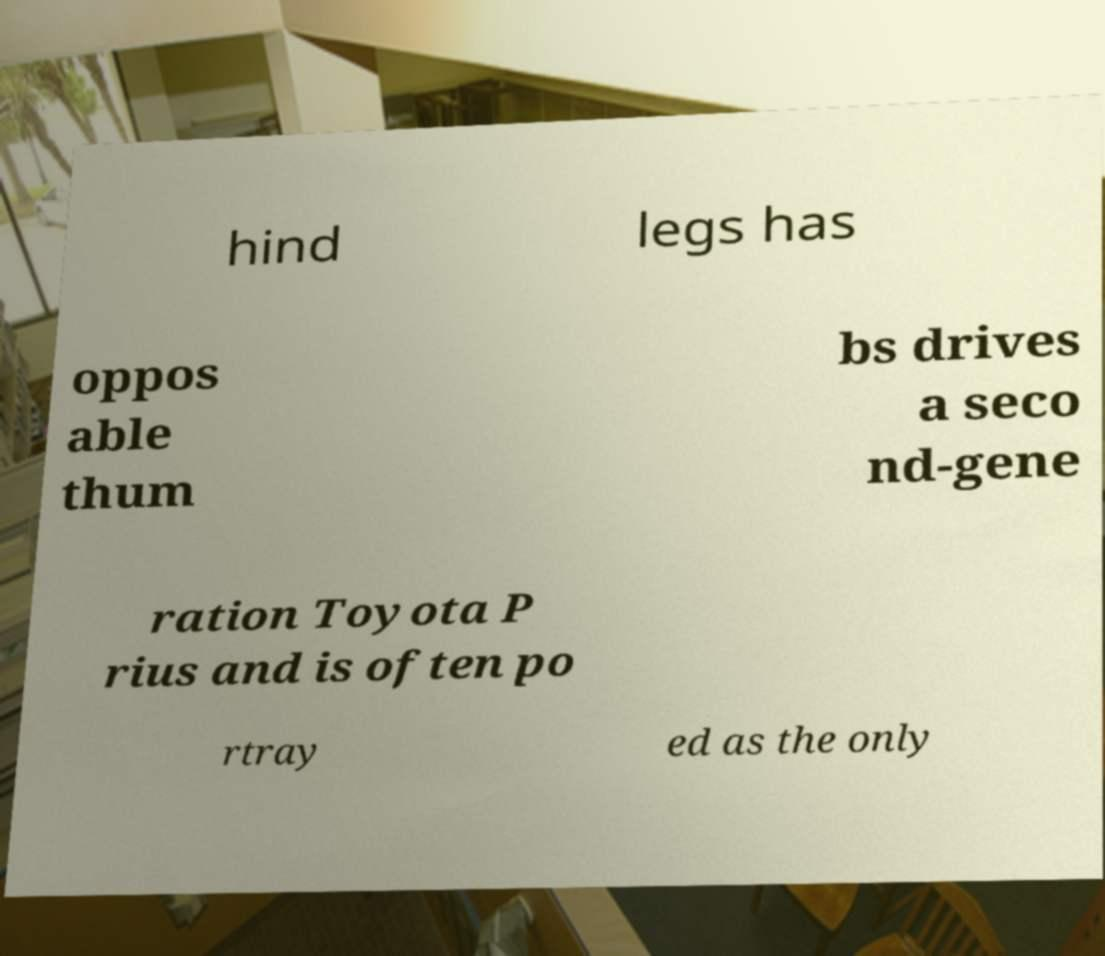I need the written content from this picture converted into text. Can you do that? hind legs has oppos able thum bs drives a seco nd-gene ration Toyota P rius and is often po rtray ed as the only 